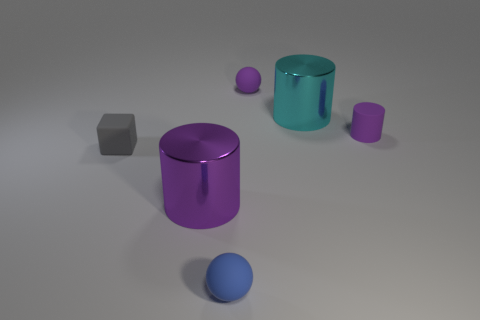What color is the other shiny object that is the same shape as the large cyan object?
Your response must be concise. Purple. Is there any other thing that is the same shape as the tiny gray matte object?
Provide a short and direct response. No. What material is the big thing that is right of the purple metallic cylinder?
Give a very brief answer. Metal. The purple rubber thing that is the same shape as the blue rubber thing is what size?
Offer a terse response. Small. How many big yellow cylinders have the same material as the cyan thing?
Your answer should be very brief. 0. How many small rubber balls have the same color as the small matte cylinder?
Offer a terse response. 1. What number of things are metallic things that are on the left side of the large cyan metal cylinder or metal objects that are on the left side of the cyan cylinder?
Make the answer very short. 1. Is the number of small purple rubber objects that are in front of the blue sphere less than the number of brown cylinders?
Give a very brief answer. No. Are there any purple shiny cylinders of the same size as the blue rubber thing?
Your answer should be very brief. No. The tiny rubber cube has what color?
Provide a succinct answer. Gray. 